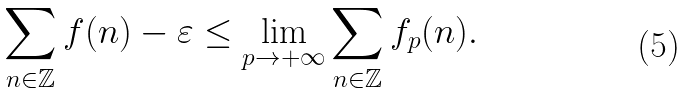<formula> <loc_0><loc_0><loc_500><loc_500>\sum _ { n \in \mathbb { Z } } f ( n ) - \varepsilon \leq \lim _ { p \rightarrow + \infty } \sum _ { n \in \mathbb { Z } } f _ { p } ( n ) .</formula> 